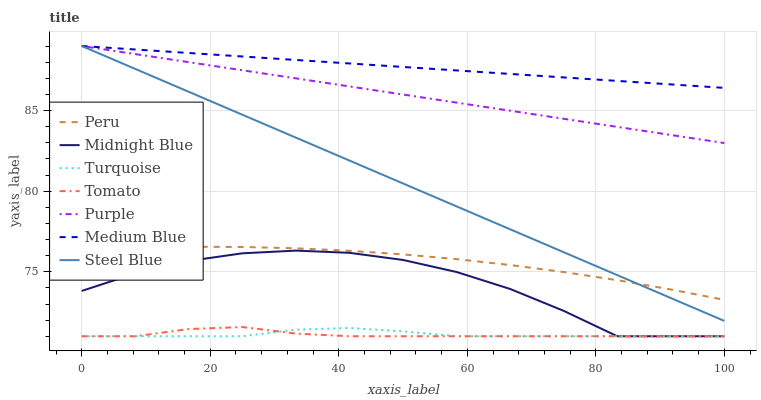Does Turquoise have the minimum area under the curve?
Answer yes or no. No. Does Turquoise have the maximum area under the curve?
Answer yes or no. No. Is Turquoise the smoothest?
Answer yes or no. No. Is Turquoise the roughest?
Answer yes or no. No. Does Purple have the lowest value?
Answer yes or no. No. Does Midnight Blue have the highest value?
Answer yes or no. No. Is Tomato less than Medium Blue?
Answer yes or no. Yes. Is Steel Blue greater than Turquoise?
Answer yes or no. Yes. Does Tomato intersect Medium Blue?
Answer yes or no. No. 